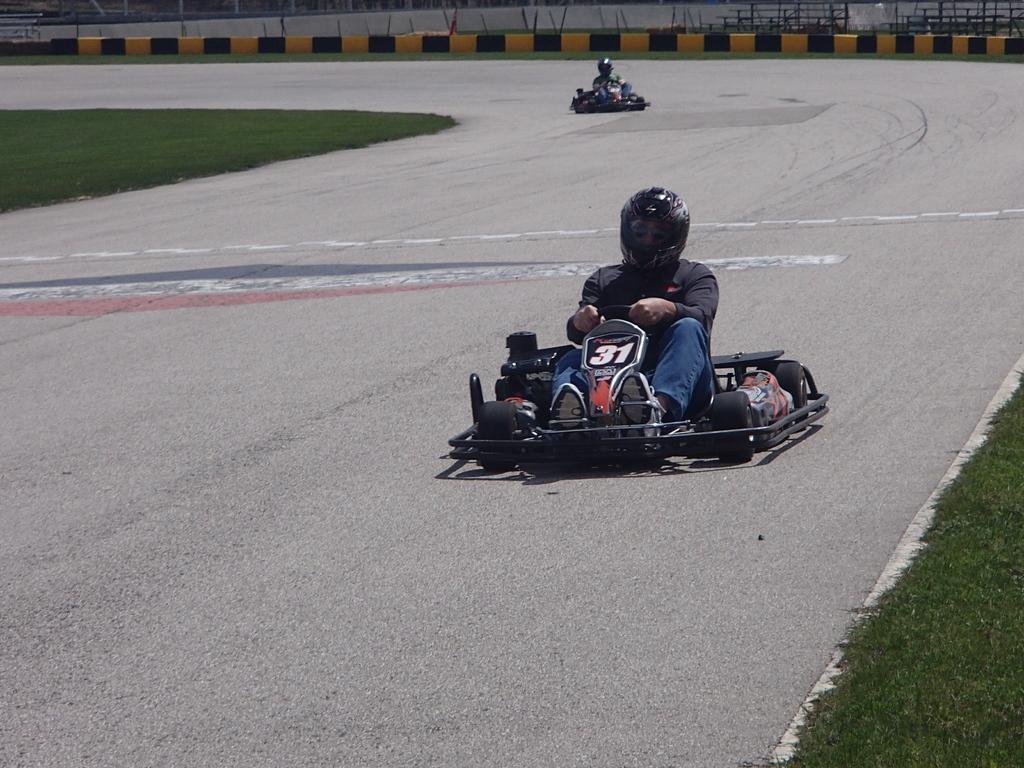How would you summarize this image in a sentence or two? In the foreground of the picture there are go kart, person, road and grass. In the background there are go-kart, fencing, grass, person. 